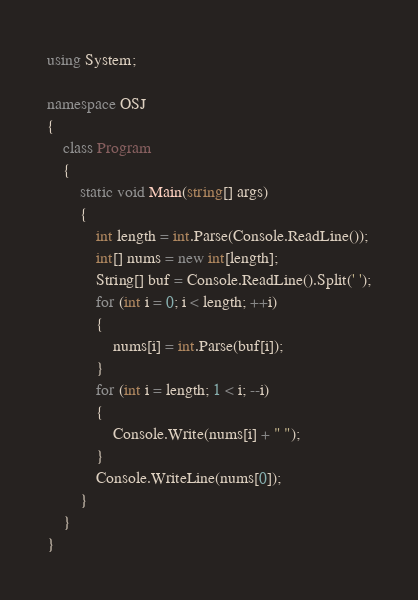Convert code to text. <code><loc_0><loc_0><loc_500><loc_500><_C#_>using System;

namespace OSJ
{
    class Program
    {
        static void Main(string[] args)
        {
            int length = int.Parse(Console.ReadLine());
            int[] nums = new int[length];
            String[] buf = Console.ReadLine().Split(' ');
            for (int i = 0; i < length; ++i)
            {
                nums[i] = int.Parse(buf[i]);
            }
            for (int i = length; 1 < i; --i)
            {
                Console.Write(nums[i] + " ");
            }
            Console.WriteLine(nums[0]);
        }
    }
}</code> 